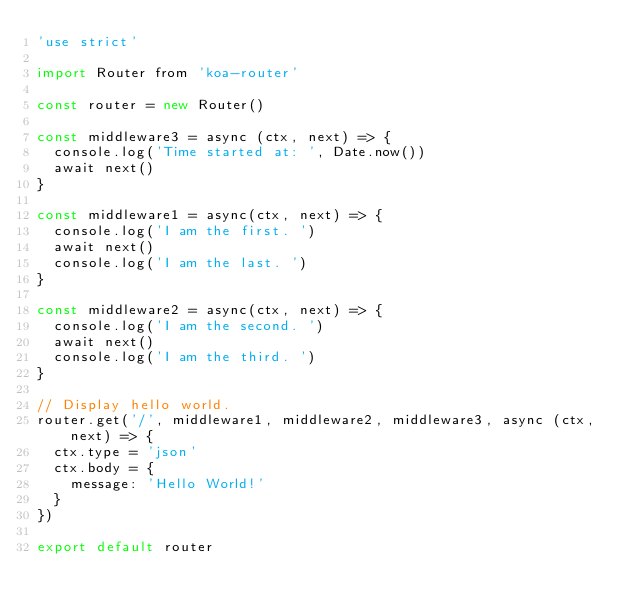Convert code to text. <code><loc_0><loc_0><loc_500><loc_500><_JavaScript_>'use strict'

import Router from 'koa-router'

const router = new Router()

const middleware3 = async (ctx, next) => {
  console.log('Time started at: ', Date.now())
  await next()
}

const middleware1 = async(ctx, next) => {
  console.log('I am the first. ')
  await next()
  console.log('I am the last. ')
}

const middleware2 = async(ctx, next) => {
  console.log('I am the second. ')
  await next()
  console.log('I am the third. ')
}

// Display hello world.
router.get('/', middleware1, middleware2, middleware3, async (ctx, next) => {
  ctx.type = 'json'
  ctx.body = {
    message: 'Hello World!'
  }
})

export default router
</code> 